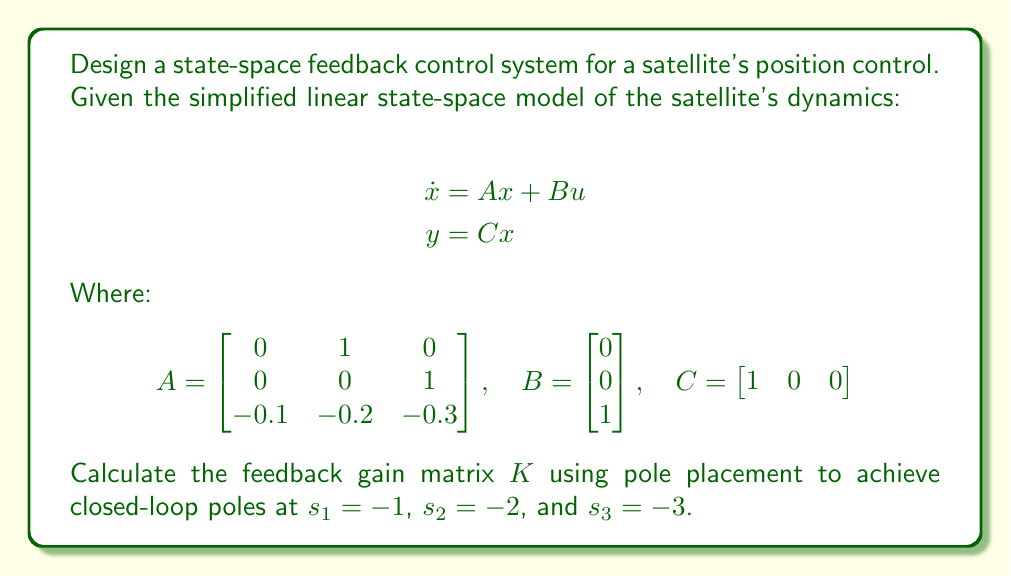Can you solve this math problem? To design the state-space feedback control system, we'll use the pole placement method to determine the feedback gain matrix $K$. The steps are as follows:

1. The closed-loop system is described by:
   $$\dot{x} = (A - BK)x$$

2. The characteristic equation of the closed-loop system is:
   $$\det(sI - (A - BK)) = 0$$

3. We want the closed-loop poles at $s_1 = -1$, $s_2 = -2$, and $s_3 = -3$. So, the desired characteristic equation is:
   $$(s + 1)(s + 2)(s + 3) = s^3 + 6s^2 + 11s + 6 = 0$$

4. Expand $\det(sI - (A - BK))$:
   $$\begin{vmatrix}
   s & -1 & 0 \\
   0 & s & -1 \\
   0.1+k_1 & 0.2+k_2 & s+0.3+k_3
   \end{vmatrix} = 0$$

5. This expands to:
   $$s^3 + (0.3+k_3)s^2 + (0.2+k_2)s + (0.1+k_1) = 0$$

6. Equating coefficients with the desired characteristic equation:
   $$0.3+k_3 = 6$$
   $$0.2+k_2 = 11$$
   $$0.1+k_1 = 6$$

7. Solving for $K$:
   $$k_3 = 5.7$$
   $$k_2 = 10.8$$
   $$k_1 = 5.9$$

Therefore, the feedback gain matrix $K$ is:
$$K = \begin{bmatrix} 5.9 & 10.8 & 5.7 \end{bmatrix}$$
Answer: $K = \begin{bmatrix} 5.9 & 10.8 & 5.7 \end{bmatrix}$ 